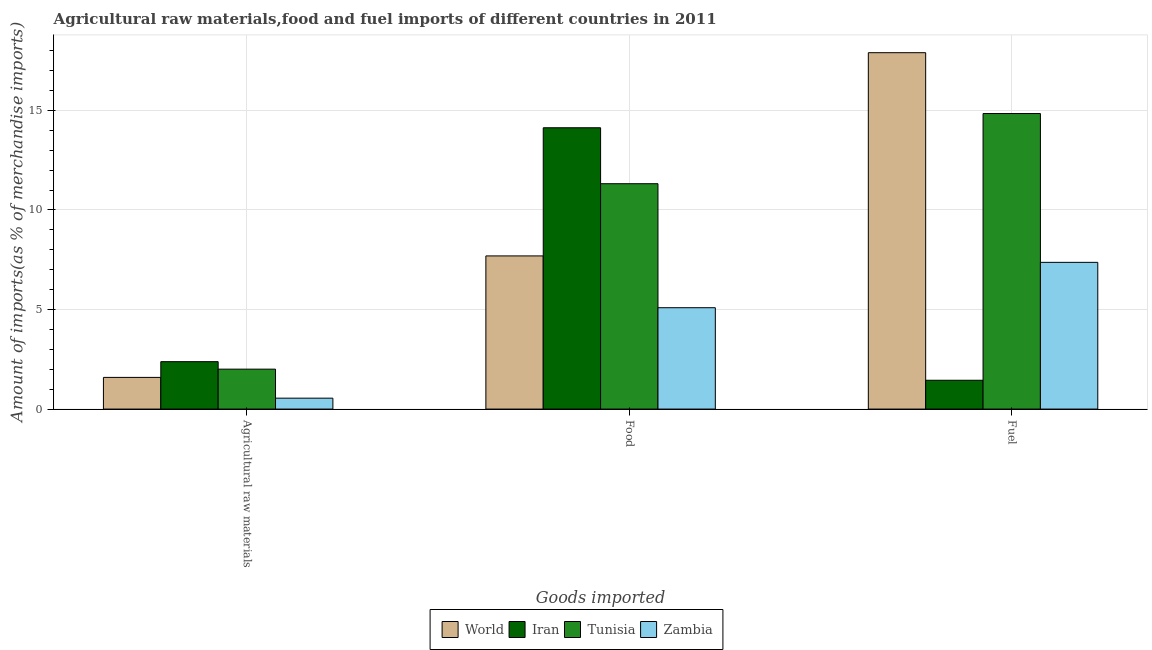Are the number of bars per tick equal to the number of legend labels?
Make the answer very short. Yes. Are the number of bars on each tick of the X-axis equal?
Offer a very short reply. Yes. How many bars are there on the 3rd tick from the left?
Your response must be concise. 4. How many bars are there on the 1st tick from the right?
Your answer should be compact. 4. What is the label of the 2nd group of bars from the left?
Provide a succinct answer. Food. What is the percentage of raw materials imports in Iran?
Ensure brevity in your answer.  2.38. Across all countries, what is the maximum percentage of food imports?
Your response must be concise. 14.13. Across all countries, what is the minimum percentage of food imports?
Offer a terse response. 5.09. In which country was the percentage of fuel imports minimum?
Make the answer very short. Iran. What is the total percentage of food imports in the graph?
Offer a terse response. 38.23. What is the difference between the percentage of fuel imports in Iran and that in Tunisia?
Make the answer very short. -13.39. What is the difference between the percentage of fuel imports in World and the percentage of raw materials imports in Iran?
Provide a succinct answer. 15.52. What is the average percentage of food imports per country?
Your response must be concise. 9.56. What is the difference between the percentage of fuel imports and percentage of raw materials imports in World?
Give a very brief answer. 16.31. In how many countries, is the percentage of raw materials imports greater than 12 %?
Offer a very short reply. 0. What is the ratio of the percentage of food imports in Zambia to that in World?
Your response must be concise. 0.66. What is the difference between the highest and the second highest percentage of fuel imports?
Make the answer very short. 3.06. What is the difference between the highest and the lowest percentage of food imports?
Give a very brief answer. 9.04. In how many countries, is the percentage of raw materials imports greater than the average percentage of raw materials imports taken over all countries?
Provide a short and direct response. 2. Is the sum of the percentage of fuel imports in Zambia and Tunisia greater than the maximum percentage of food imports across all countries?
Provide a succinct answer. Yes. What does the 2nd bar from the left in Food represents?
Make the answer very short. Iran. What does the 3rd bar from the right in Agricultural raw materials represents?
Give a very brief answer. Iran. How many bars are there?
Offer a terse response. 12. How many countries are there in the graph?
Give a very brief answer. 4. What is the difference between two consecutive major ticks on the Y-axis?
Ensure brevity in your answer.  5. Does the graph contain grids?
Provide a short and direct response. Yes. How are the legend labels stacked?
Your answer should be very brief. Horizontal. What is the title of the graph?
Make the answer very short. Agricultural raw materials,food and fuel imports of different countries in 2011. Does "Georgia" appear as one of the legend labels in the graph?
Make the answer very short. No. What is the label or title of the X-axis?
Give a very brief answer. Goods imported. What is the label or title of the Y-axis?
Offer a very short reply. Amount of imports(as % of merchandise imports). What is the Amount of imports(as % of merchandise imports) in World in Agricultural raw materials?
Keep it short and to the point. 1.59. What is the Amount of imports(as % of merchandise imports) in Iran in Agricultural raw materials?
Ensure brevity in your answer.  2.38. What is the Amount of imports(as % of merchandise imports) in Tunisia in Agricultural raw materials?
Make the answer very short. 2.01. What is the Amount of imports(as % of merchandise imports) in Zambia in Agricultural raw materials?
Offer a very short reply. 0.55. What is the Amount of imports(as % of merchandise imports) of World in Food?
Offer a very short reply. 7.69. What is the Amount of imports(as % of merchandise imports) of Iran in Food?
Your response must be concise. 14.13. What is the Amount of imports(as % of merchandise imports) of Tunisia in Food?
Provide a succinct answer. 11.32. What is the Amount of imports(as % of merchandise imports) of Zambia in Food?
Provide a short and direct response. 5.09. What is the Amount of imports(as % of merchandise imports) of World in Fuel?
Give a very brief answer. 17.9. What is the Amount of imports(as % of merchandise imports) of Iran in Fuel?
Provide a succinct answer. 1.45. What is the Amount of imports(as % of merchandise imports) of Tunisia in Fuel?
Ensure brevity in your answer.  14.84. What is the Amount of imports(as % of merchandise imports) of Zambia in Fuel?
Your answer should be compact. 7.37. Across all Goods imported, what is the maximum Amount of imports(as % of merchandise imports) of World?
Your answer should be very brief. 17.9. Across all Goods imported, what is the maximum Amount of imports(as % of merchandise imports) of Iran?
Provide a succinct answer. 14.13. Across all Goods imported, what is the maximum Amount of imports(as % of merchandise imports) in Tunisia?
Offer a terse response. 14.84. Across all Goods imported, what is the maximum Amount of imports(as % of merchandise imports) of Zambia?
Offer a very short reply. 7.37. Across all Goods imported, what is the minimum Amount of imports(as % of merchandise imports) in World?
Your answer should be very brief. 1.59. Across all Goods imported, what is the minimum Amount of imports(as % of merchandise imports) in Iran?
Provide a short and direct response. 1.45. Across all Goods imported, what is the minimum Amount of imports(as % of merchandise imports) in Tunisia?
Keep it short and to the point. 2.01. Across all Goods imported, what is the minimum Amount of imports(as % of merchandise imports) of Zambia?
Your answer should be compact. 0.55. What is the total Amount of imports(as % of merchandise imports) in World in the graph?
Give a very brief answer. 27.18. What is the total Amount of imports(as % of merchandise imports) of Iran in the graph?
Offer a very short reply. 17.96. What is the total Amount of imports(as % of merchandise imports) in Tunisia in the graph?
Your answer should be compact. 28.16. What is the total Amount of imports(as % of merchandise imports) in Zambia in the graph?
Your answer should be very brief. 13.01. What is the difference between the Amount of imports(as % of merchandise imports) in World in Agricultural raw materials and that in Food?
Keep it short and to the point. -6.1. What is the difference between the Amount of imports(as % of merchandise imports) in Iran in Agricultural raw materials and that in Food?
Provide a short and direct response. -11.75. What is the difference between the Amount of imports(as % of merchandise imports) of Tunisia in Agricultural raw materials and that in Food?
Ensure brevity in your answer.  -9.31. What is the difference between the Amount of imports(as % of merchandise imports) in Zambia in Agricultural raw materials and that in Food?
Your response must be concise. -4.54. What is the difference between the Amount of imports(as % of merchandise imports) of World in Agricultural raw materials and that in Fuel?
Provide a succinct answer. -16.31. What is the difference between the Amount of imports(as % of merchandise imports) of Iran in Agricultural raw materials and that in Fuel?
Give a very brief answer. 0.93. What is the difference between the Amount of imports(as % of merchandise imports) in Tunisia in Agricultural raw materials and that in Fuel?
Provide a short and direct response. -12.84. What is the difference between the Amount of imports(as % of merchandise imports) of Zambia in Agricultural raw materials and that in Fuel?
Ensure brevity in your answer.  -6.82. What is the difference between the Amount of imports(as % of merchandise imports) of World in Food and that in Fuel?
Give a very brief answer. -10.21. What is the difference between the Amount of imports(as % of merchandise imports) in Iran in Food and that in Fuel?
Make the answer very short. 12.68. What is the difference between the Amount of imports(as % of merchandise imports) of Tunisia in Food and that in Fuel?
Offer a terse response. -3.52. What is the difference between the Amount of imports(as % of merchandise imports) in Zambia in Food and that in Fuel?
Your answer should be very brief. -2.28. What is the difference between the Amount of imports(as % of merchandise imports) in World in Agricultural raw materials and the Amount of imports(as % of merchandise imports) in Iran in Food?
Offer a terse response. -12.54. What is the difference between the Amount of imports(as % of merchandise imports) in World in Agricultural raw materials and the Amount of imports(as % of merchandise imports) in Tunisia in Food?
Keep it short and to the point. -9.73. What is the difference between the Amount of imports(as % of merchandise imports) of World in Agricultural raw materials and the Amount of imports(as % of merchandise imports) of Zambia in Food?
Make the answer very short. -3.5. What is the difference between the Amount of imports(as % of merchandise imports) of Iran in Agricultural raw materials and the Amount of imports(as % of merchandise imports) of Tunisia in Food?
Your answer should be very brief. -8.94. What is the difference between the Amount of imports(as % of merchandise imports) of Iran in Agricultural raw materials and the Amount of imports(as % of merchandise imports) of Zambia in Food?
Provide a short and direct response. -2.71. What is the difference between the Amount of imports(as % of merchandise imports) of Tunisia in Agricultural raw materials and the Amount of imports(as % of merchandise imports) of Zambia in Food?
Offer a very short reply. -3.09. What is the difference between the Amount of imports(as % of merchandise imports) of World in Agricultural raw materials and the Amount of imports(as % of merchandise imports) of Iran in Fuel?
Your answer should be compact. 0.14. What is the difference between the Amount of imports(as % of merchandise imports) in World in Agricultural raw materials and the Amount of imports(as % of merchandise imports) in Tunisia in Fuel?
Keep it short and to the point. -13.25. What is the difference between the Amount of imports(as % of merchandise imports) in World in Agricultural raw materials and the Amount of imports(as % of merchandise imports) in Zambia in Fuel?
Ensure brevity in your answer.  -5.78. What is the difference between the Amount of imports(as % of merchandise imports) in Iran in Agricultural raw materials and the Amount of imports(as % of merchandise imports) in Tunisia in Fuel?
Provide a short and direct response. -12.46. What is the difference between the Amount of imports(as % of merchandise imports) of Iran in Agricultural raw materials and the Amount of imports(as % of merchandise imports) of Zambia in Fuel?
Your answer should be very brief. -4.99. What is the difference between the Amount of imports(as % of merchandise imports) in Tunisia in Agricultural raw materials and the Amount of imports(as % of merchandise imports) in Zambia in Fuel?
Provide a succinct answer. -5.36. What is the difference between the Amount of imports(as % of merchandise imports) in World in Food and the Amount of imports(as % of merchandise imports) in Iran in Fuel?
Your answer should be very brief. 6.24. What is the difference between the Amount of imports(as % of merchandise imports) in World in Food and the Amount of imports(as % of merchandise imports) in Tunisia in Fuel?
Give a very brief answer. -7.15. What is the difference between the Amount of imports(as % of merchandise imports) of World in Food and the Amount of imports(as % of merchandise imports) of Zambia in Fuel?
Your answer should be compact. 0.32. What is the difference between the Amount of imports(as % of merchandise imports) of Iran in Food and the Amount of imports(as % of merchandise imports) of Tunisia in Fuel?
Your answer should be very brief. -0.71. What is the difference between the Amount of imports(as % of merchandise imports) of Iran in Food and the Amount of imports(as % of merchandise imports) of Zambia in Fuel?
Your answer should be very brief. 6.76. What is the difference between the Amount of imports(as % of merchandise imports) in Tunisia in Food and the Amount of imports(as % of merchandise imports) in Zambia in Fuel?
Offer a terse response. 3.95. What is the average Amount of imports(as % of merchandise imports) of World per Goods imported?
Your response must be concise. 9.06. What is the average Amount of imports(as % of merchandise imports) in Iran per Goods imported?
Provide a succinct answer. 5.99. What is the average Amount of imports(as % of merchandise imports) of Tunisia per Goods imported?
Give a very brief answer. 9.39. What is the average Amount of imports(as % of merchandise imports) of Zambia per Goods imported?
Offer a terse response. 4.34. What is the difference between the Amount of imports(as % of merchandise imports) in World and Amount of imports(as % of merchandise imports) in Iran in Agricultural raw materials?
Offer a terse response. -0.79. What is the difference between the Amount of imports(as % of merchandise imports) in World and Amount of imports(as % of merchandise imports) in Tunisia in Agricultural raw materials?
Provide a short and direct response. -0.41. What is the difference between the Amount of imports(as % of merchandise imports) of World and Amount of imports(as % of merchandise imports) of Zambia in Agricultural raw materials?
Ensure brevity in your answer.  1.04. What is the difference between the Amount of imports(as % of merchandise imports) of Iran and Amount of imports(as % of merchandise imports) of Tunisia in Agricultural raw materials?
Your answer should be compact. 0.38. What is the difference between the Amount of imports(as % of merchandise imports) in Iran and Amount of imports(as % of merchandise imports) in Zambia in Agricultural raw materials?
Ensure brevity in your answer.  1.83. What is the difference between the Amount of imports(as % of merchandise imports) in Tunisia and Amount of imports(as % of merchandise imports) in Zambia in Agricultural raw materials?
Your answer should be very brief. 1.46. What is the difference between the Amount of imports(as % of merchandise imports) of World and Amount of imports(as % of merchandise imports) of Iran in Food?
Make the answer very short. -6.44. What is the difference between the Amount of imports(as % of merchandise imports) in World and Amount of imports(as % of merchandise imports) in Tunisia in Food?
Offer a terse response. -3.63. What is the difference between the Amount of imports(as % of merchandise imports) in World and Amount of imports(as % of merchandise imports) in Zambia in Food?
Make the answer very short. 2.6. What is the difference between the Amount of imports(as % of merchandise imports) of Iran and Amount of imports(as % of merchandise imports) of Tunisia in Food?
Your answer should be compact. 2.81. What is the difference between the Amount of imports(as % of merchandise imports) of Iran and Amount of imports(as % of merchandise imports) of Zambia in Food?
Your answer should be very brief. 9.04. What is the difference between the Amount of imports(as % of merchandise imports) of Tunisia and Amount of imports(as % of merchandise imports) of Zambia in Food?
Give a very brief answer. 6.23. What is the difference between the Amount of imports(as % of merchandise imports) of World and Amount of imports(as % of merchandise imports) of Iran in Fuel?
Your answer should be compact. 16.45. What is the difference between the Amount of imports(as % of merchandise imports) of World and Amount of imports(as % of merchandise imports) of Tunisia in Fuel?
Ensure brevity in your answer.  3.06. What is the difference between the Amount of imports(as % of merchandise imports) of World and Amount of imports(as % of merchandise imports) of Zambia in Fuel?
Offer a terse response. 10.53. What is the difference between the Amount of imports(as % of merchandise imports) of Iran and Amount of imports(as % of merchandise imports) of Tunisia in Fuel?
Your response must be concise. -13.39. What is the difference between the Amount of imports(as % of merchandise imports) of Iran and Amount of imports(as % of merchandise imports) of Zambia in Fuel?
Offer a terse response. -5.92. What is the difference between the Amount of imports(as % of merchandise imports) of Tunisia and Amount of imports(as % of merchandise imports) of Zambia in Fuel?
Make the answer very short. 7.47. What is the ratio of the Amount of imports(as % of merchandise imports) of World in Agricultural raw materials to that in Food?
Offer a very short reply. 0.21. What is the ratio of the Amount of imports(as % of merchandise imports) in Iran in Agricultural raw materials to that in Food?
Offer a terse response. 0.17. What is the ratio of the Amount of imports(as % of merchandise imports) of Tunisia in Agricultural raw materials to that in Food?
Your answer should be compact. 0.18. What is the ratio of the Amount of imports(as % of merchandise imports) of Zambia in Agricultural raw materials to that in Food?
Your response must be concise. 0.11. What is the ratio of the Amount of imports(as % of merchandise imports) in World in Agricultural raw materials to that in Fuel?
Offer a very short reply. 0.09. What is the ratio of the Amount of imports(as % of merchandise imports) in Iran in Agricultural raw materials to that in Fuel?
Keep it short and to the point. 1.65. What is the ratio of the Amount of imports(as % of merchandise imports) of Tunisia in Agricultural raw materials to that in Fuel?
Your answer should be compact. 0.14. What is the ratio of the Amount of imports(as % of merchandise imports) in Zambia in Agricultural raw materials to that in Fuel?
Make the answer very short. 0.07. What is the ratio of the Amount of imports(as % of merchandise imports) in World in Food to that in Fuel?
Offer a terse response. 0.43. What is the ratio of the Amount of imports(as % of merchandise imports) of Iran in Food to that in Fuel?
Your answer should be compact. 9.76. What is the ratio of the Amount of imports(as % of merchandise imports) of Tunisia in Food to that in Fuel?
Offer a terse response. 0.76. What is the ratio of the Amount of imports(as % of merchandise imports) of Zambia in Food to that in Fuel?
Offer a terse response. 0.69. What is the difference between the highest and the second highest Amount of imports(as % of merchandise imports) in World?
Offer a very short reply. 10.21. What is the difference between the highest and the second highest Amount of imports(as % of merchandise imports) in Iran?
Your response must be concise. 11.75. What is the difference between the highest and the second highest Amount of imports(as % of merchandise imports) of Tunisia?
Offer a very short reply. 3.52. What is the difference between the highest and the second highest Amount of imports(as % of merchandise imports) of Zambia?
Offer a very short reply. 2.28. What is the difference between the highest and the lowest Amount of imports(as % of merchandise imports) in World?
Give a very brief answer. 16.31. What is the difference between the highest and the lowest Amount of imports(as % of merchandise imports) of Iran?
Your answer should be compact. 12.68. What is the difference between the highest and the lowest Amount of imports(as % of merchandise imports) in Tunisia?
Make the answer very short. 12.84. What is the difference between the highest and the lowest Amount of imports(as % of merchandise imports) of Zambia?
Your response must be concise. 6.82. 